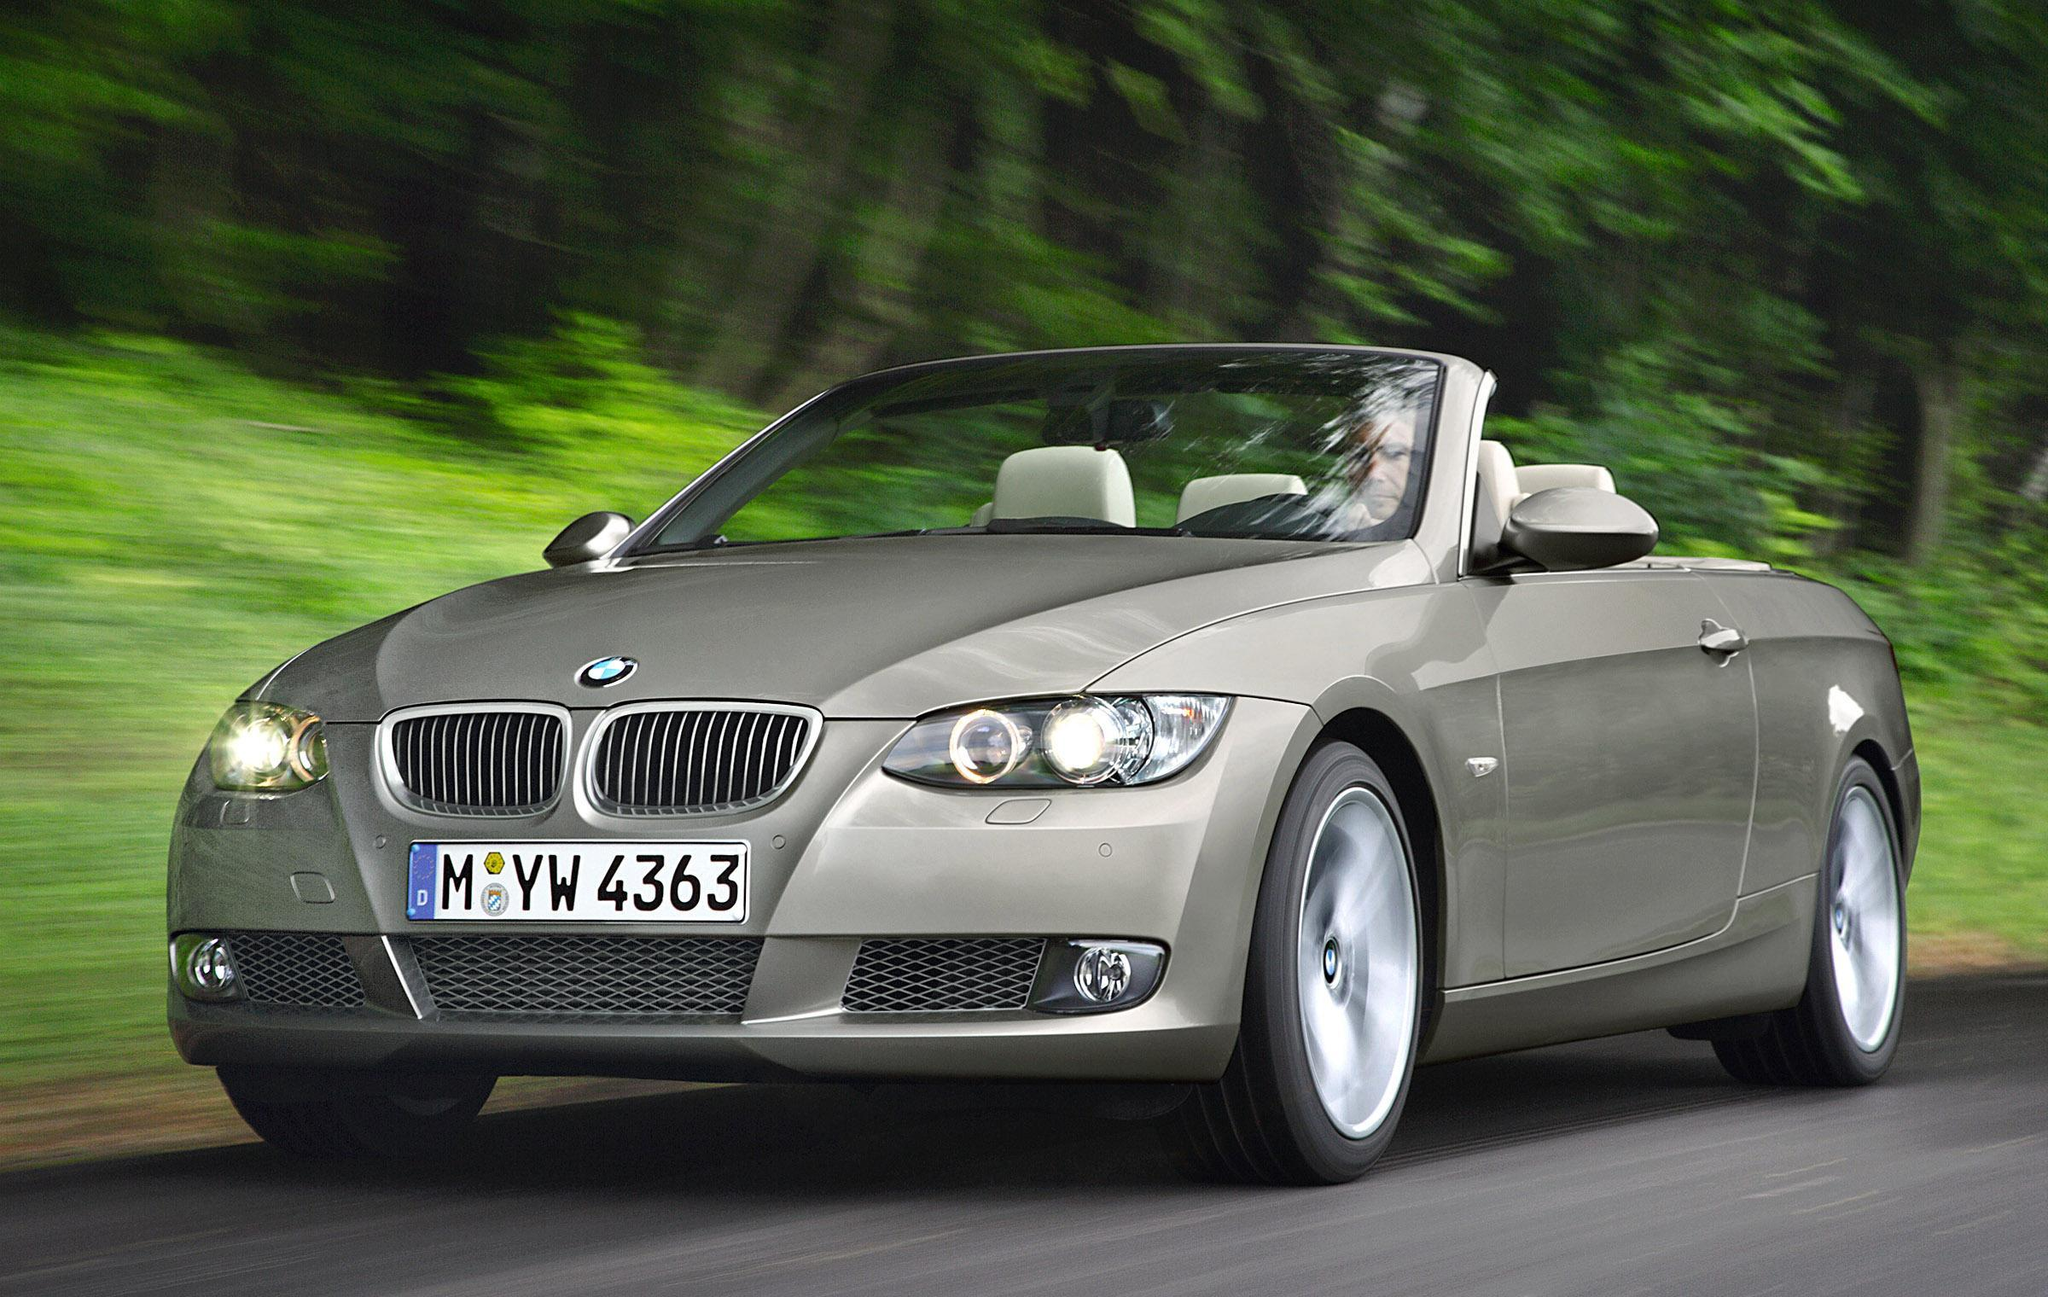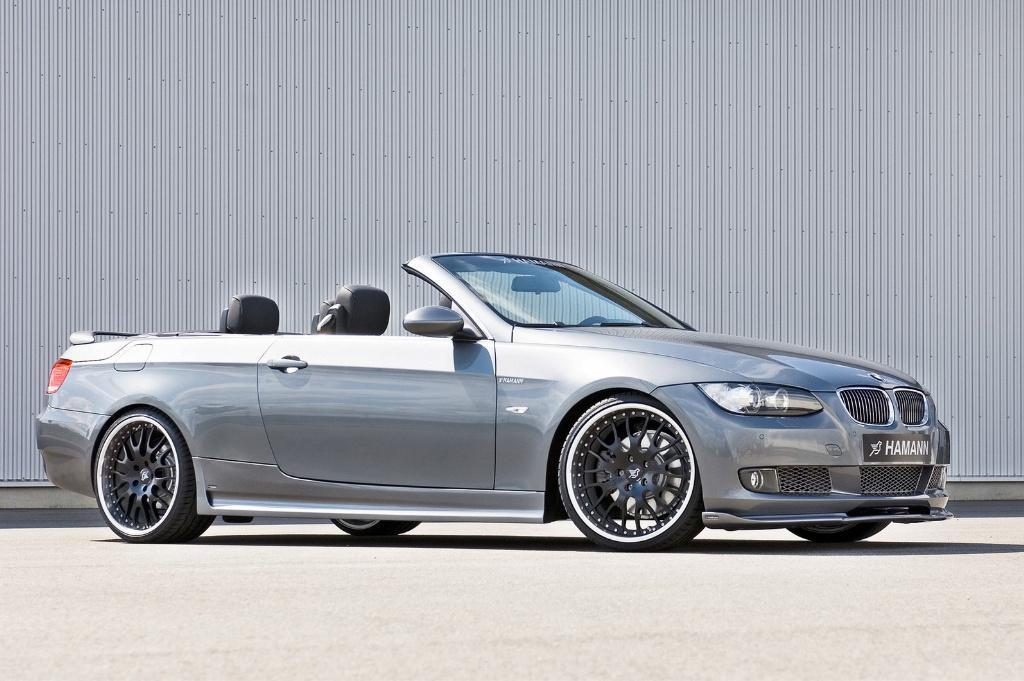The first image is the image on the left, the second image is the image on the right. Given the left and right images, does the statement "In each image there is a convertible with its top down without any people present, but the cars are facing the opposite direction." hold true? Answer yes or no. No. The first image is the image on the left, the second image is the image on the right. Considering the images on both sides, is "Each image contains one topless convertible displayed at an angle, and the cars on the left and right are back-to-back, facing outward." valid? Answer yes or no. Yes. 